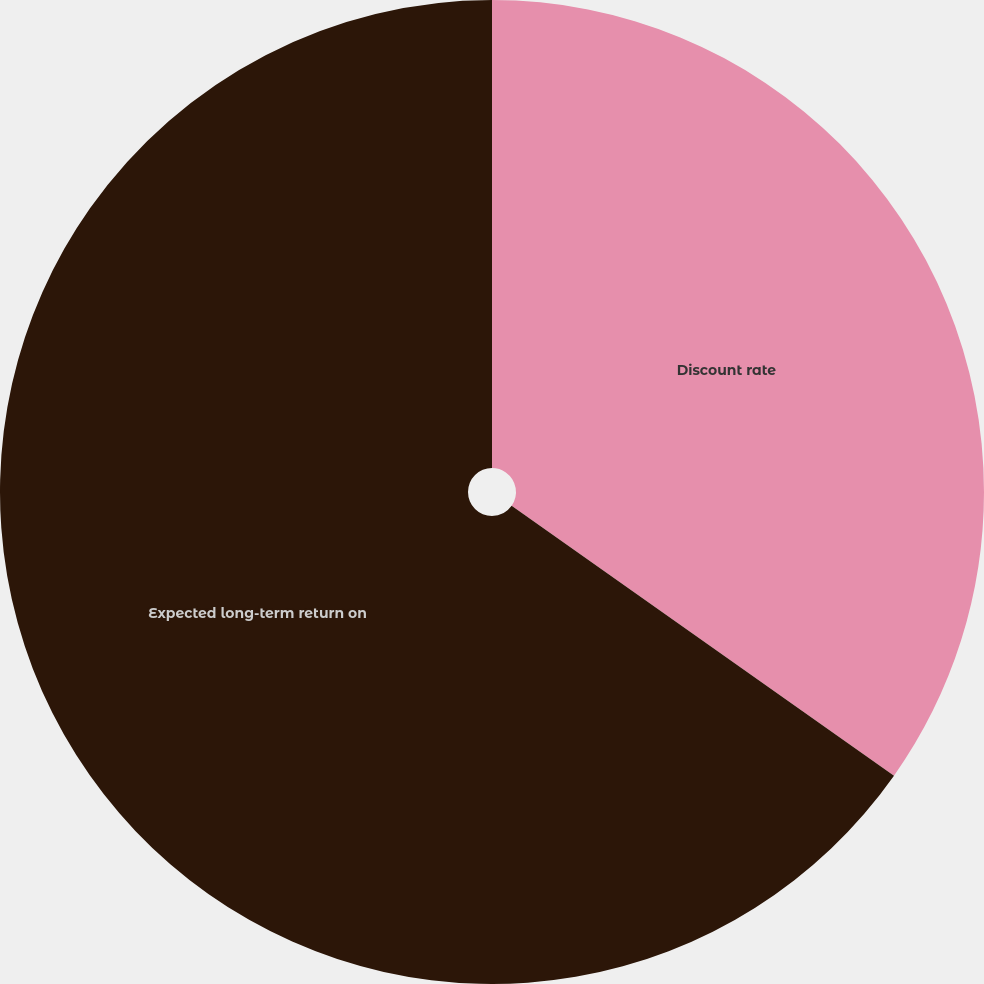Convert chart to OTSL. <chart><loc_0><loc_0><loc_500><loc_500><pie_chart><fcel>Discount rate<fcel>Expected long-term return on<nl><fcel>34.78%<fcel>65.22%<nl></chart> 